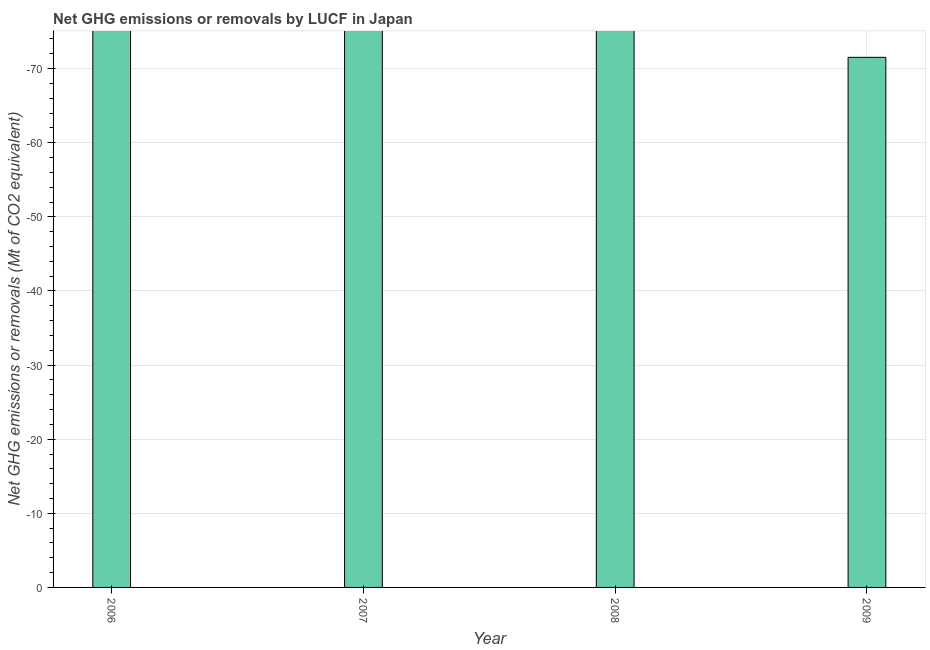What is the title of the graph?
Offer a terse response. Net GHG emissions or removals by LUCF in Japan. What is the label or title of the X-axis?
Provide a succinct answer. Year. What is the label or title of the Y-axis?
Provide a succinct answer. Net GHG emissions or removals (Mt of CO2 equivalent). What is the ghg net emissions or removals in 2009?
Provide a short and direct response. 0. Across all years, what is the minimum ghg net emissions or removals?
Your answer should be compact. 0. What is the average ghg net emissions or removals per year?
Your answer should be very brief. 0. What is the median ghg net emissions or removals?
Ensure brevity in your answer.  0. In how many years, is the ghg net emissions or removals greater than the average ghg net emissions or removals taken over all years?
Provide a short and direct response. 0. Are all the bars in the graph horizontal?
Ensure brevity in your answer.  No. What is the difference between two consecutive major ticks on the Y-axis?
Offer a terse response. 10. What is the Net GHG emissions or removals (Mt of CO2 equivalent) of 2006?
Your response must be concise. 0. What is the Net GHG emissions or removals (Mt of CO2 equivalent) in 2007?
Make the answer very short. 0. What is the Net GHG emissions or removals (Mt of CO2 equivalent) of 2009?
Give a very brief answer. 0. 